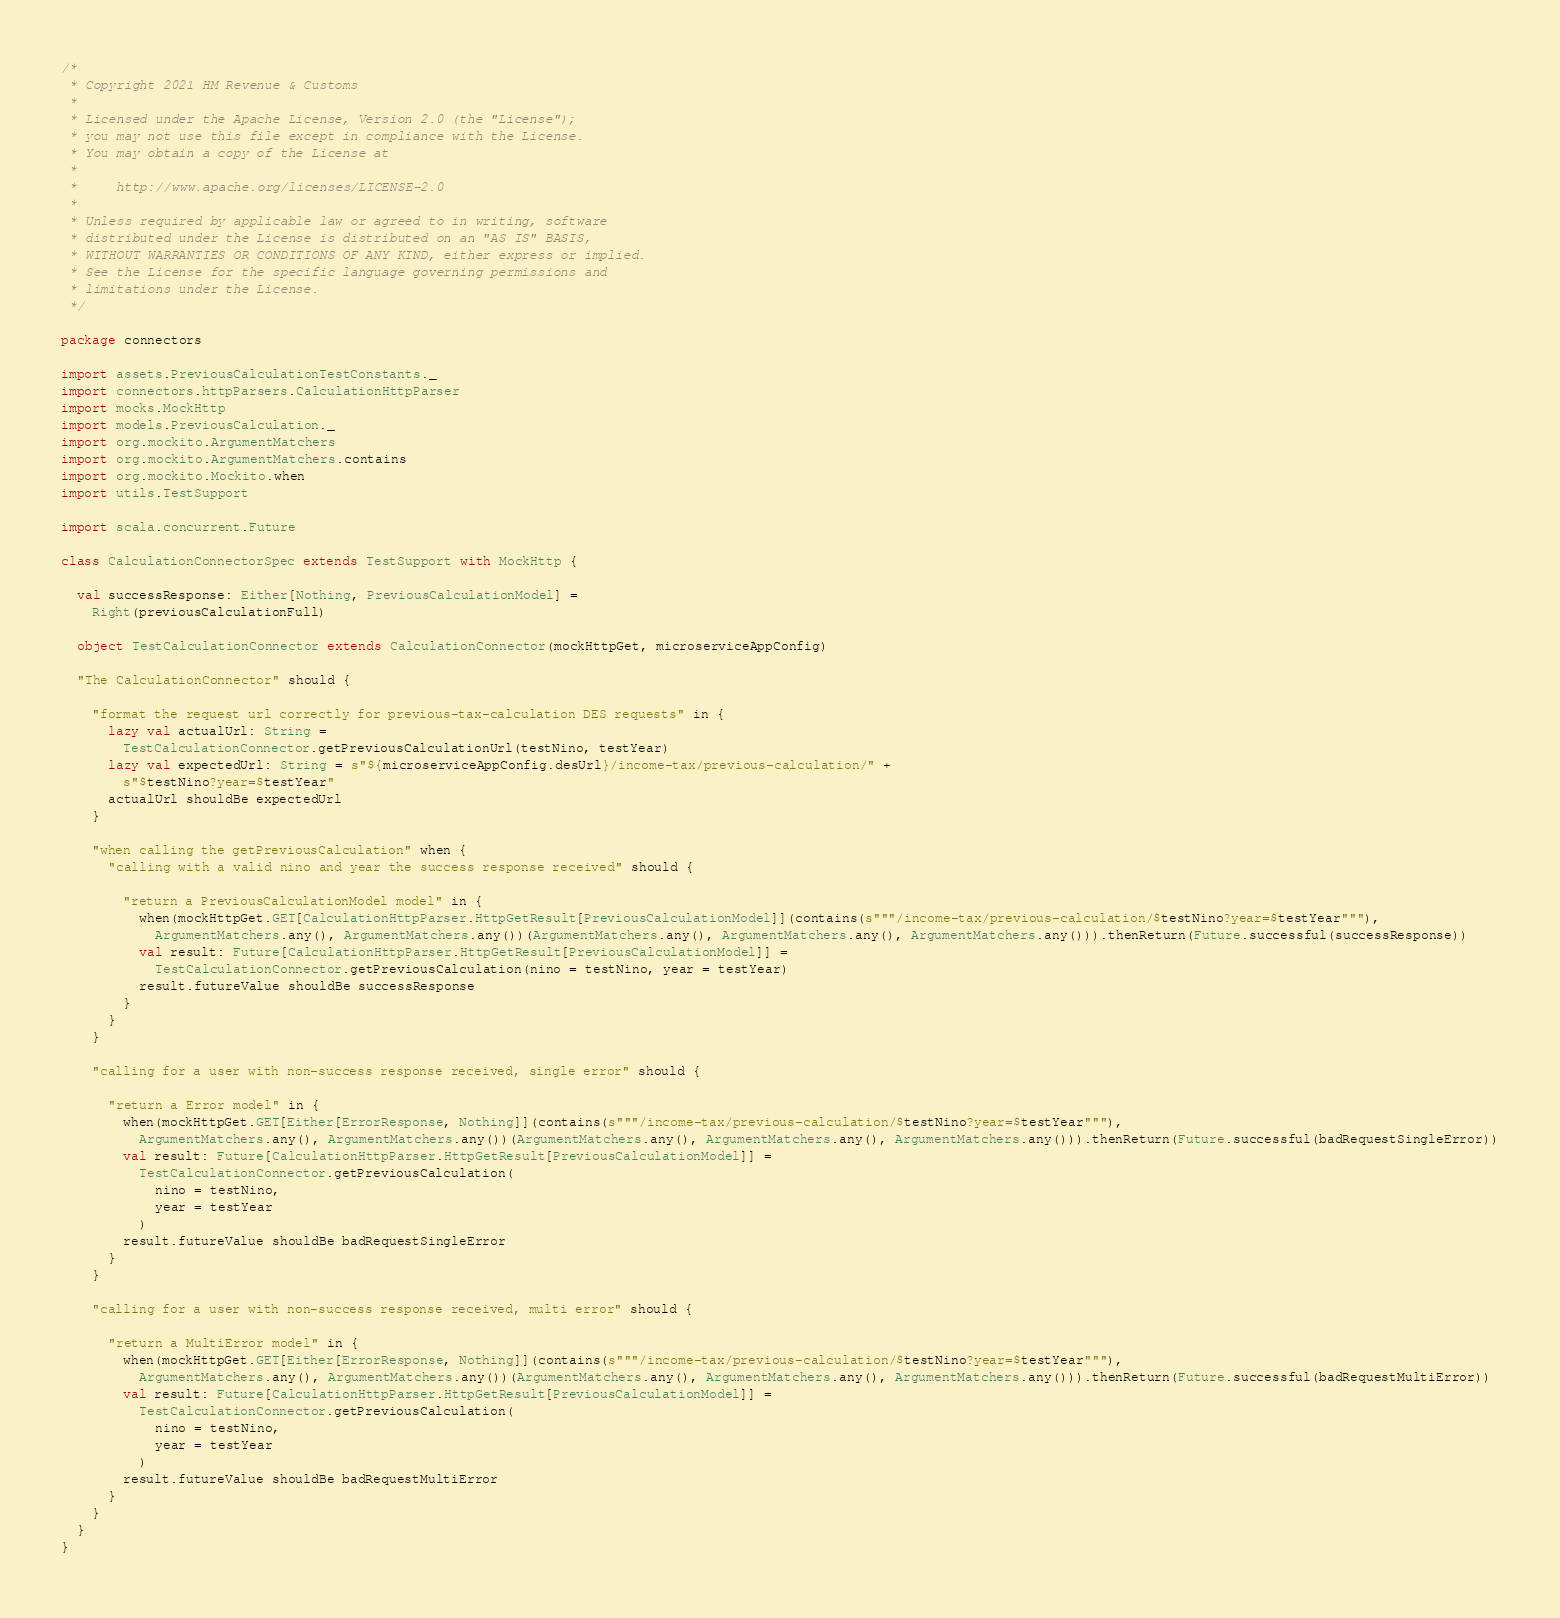Convert code to text. <code><loc_0><loc_0><loc_500><loc_500><_Scala_>/*
 * Copyright 2021 HM Revenue & Customs
 *
 * Licensed under the Apache License, Version 2.0 (the "License");
 * you may not use this file except in compliance with the License.
 * You may obtain a copy of the License at
 *
 *     http://www.apache.org/licenses/LICENSE-2.0
 *
 * Unless required by applicable law or agreed to in writing, software
 * distributed under the License is distributed on an "AS IS" BASIS,
 * WITHOUT WARRANTIES OR CONDITIONS OF ANY KIND, either express or implied.
 * See the License for the specific language governing permissions and
 * limitations under the License.
 */

package connectors

import assets.PreviousCalculationTestConstants._
import connectors.httpParsers.CalculationHttpParser
import mocks.MockHttp
import models.PreviousCalculation._
import org.mockito.ArgumentMatchers
import org.mockito.ArgumentMatchers.contains
import org.mockito.Mockito.when
import utils.TestSupport

import scala.concurrent.Future

class CalculationConnectorSpec extends TestSupport with MockHttp {

  val successResponse: Either[Nothing, PreviousCalculationModel] =
    Right(previousCalculationFull)

  object TestCalculationConnector extends CalculationConnector(mockHttpGet, microserviceAppConfig)

  "The CalculationConnector" should {

    "format the request url correctly for previous-tax-calculation DES requests" in {
      lazy val actualUrl: String =
        TestCalculationConnector.getPreviousCalculationUrl(testNino, testYear)
      lazy val expectedUrl: String = s"${microserviceAppConfig.desUrl}/income-tax/previous-calculation/" +
        s"$testNino?year=$testYear"
      actualUrl shouldBe expectedUrl
    }

    "when calling the getPreviousCalculation" when {
      "calling with a valid nino and year the success response received" should {

        "return a PreviousCalculationModel model" in {
          when(mockHttpGet.GET[CalculationHttpParser.HttpGetResult[PreviousCalculationModel]](contains(s"""/income-tax/previous-calculation/$testNino?year=$testYear"""),
            ArgumentMatchers.any(), ArgumentMatchers.any())(ArgumentMatchers.any(), ArgumentMatchers.any(), ArgumentMatchers.any())).thenReturn(Future.successful(successResponse))
          val result: Future[CalculationHttpParser.HttpGetResult[PreviousCalculationModel]] =
            TestCalculationConnector.getPreviousCalculation(nino = testNino, year = testYear)
          result.futureValue shouldBe successResponse
        }
      }
    }

    "calling for a user with non-success response received, single error" should {

      "return a Error model" in {
        when(mockHttpGet.GET[Either[ErrorResponse, Nothing]](contains(s"""/income-tax/previous-calculation/$testNino?year=$testYear"""),
          ArgumentMatchers.any(), ArgumentMatchers.any())(ArgumentMatchers.any(), ArgumentMatchers.any(), ArgumentMatchers.any())).thenReturn(Future.successful(badRequestSingleError))
        val result: Future[CalculationHttpParser.HttpGetResult[PreviousCalculationModel]] =
          TestCalculationConnector.getPreviousCalculation(
            nino = testNino,
            year = testYear
          )
        result.futureValue shouldBe badRequestSingleError
      }
    }

    "calling for a user with non-success response received, multi error" should {

      "return a MultiError model" in {
        when(mockHttpGet.GET[Either[ErrorResponse, Nothing]](contains(s"""/income-tax/previous-calculation/$testNino?year=$testYear"""),
          ArgumentMatchers.any(), ArgumentMatchers.any())(ArgumentMatchers.any(), ArgumentMatchers.any(), ArgumentMatchers.any())).thenReturn(Future.successful(badRequestMultiError))
        val result: Future[CalculationHttpParser.HttpGetResult[PreviousCalculationModel]] =
          TestCalculationConnector.getPreviousCalculation(
            nino = testNino,
            year = testYear
          )
        result.futureValue shouldBe badRequestMultiError
      }
    }
  }
}
</code> 